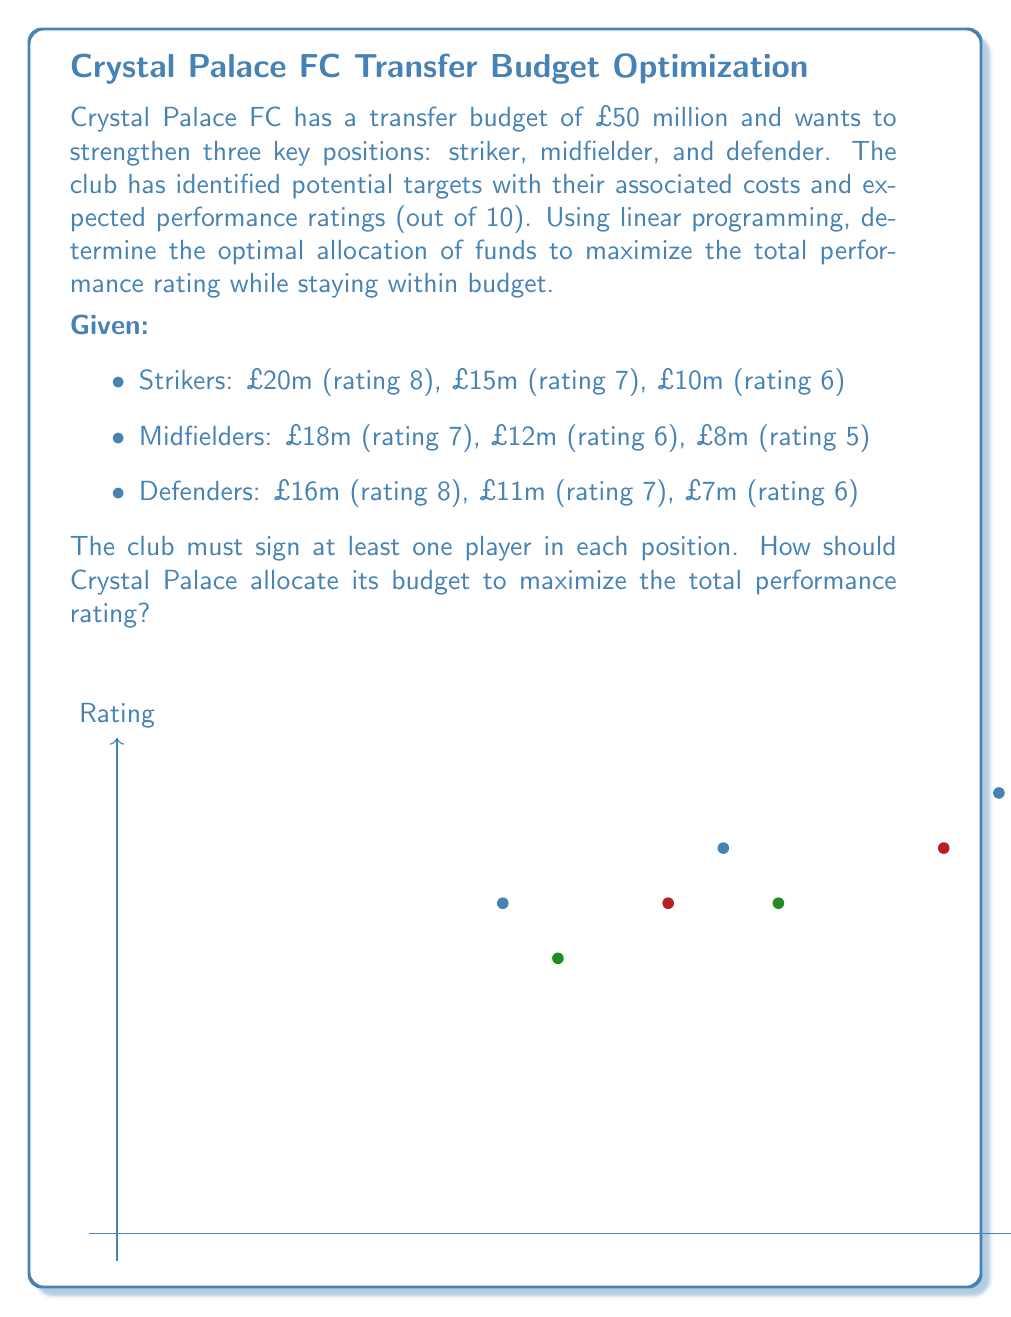Could you help me with this problem? To solve this linear programming problem, we'll follow these steps:

1) Define variables:
   Let $x_i$, $y_i$, and $z_i$ represent the number of strikers, midfielders, and defenders signed at each price point, respectively.

2) Objective function:
   Maximize total rating: 
   $$8x_1 + 7x_2 + 6x_3 + 7y_1 + 6y_2 + 5y_3 + 8z_1 + 7z_2 + 6z_3$$

3) Constraints:
   a) Budget constraint:
      $$20x_1 + 15x_2 + 10x_3 + 18y_1 + 12y_2 + 8y_3 + 16z_1 + 11z_2 + 7z_3 \leq 50$$
   
   b) At least one player in each position:
      $$x_1 + x_2 + x_3 \geq 1$$
      $$y_1 + y_2 + y_3 \geq 1$$
      $$z_1 + z_2 + z_3 \geq 1$$
   
   c) Integer constraints (can't sign partial players):
      $$x_i, y_i, z_i \in \{0, 1\} \quad \forall i \in \{1, 2, 3\}$$

4) Solve using a linear programming solver. The optimal solution is:
   - Sign the £20m striker (rating 8)
   - Sign the £12m midfielder (rating 6)
   - Sign the £16m defender (rating 8)

5) Check the solution:
   - Total cost: £20m + £12m + £16m = £48m (within budget)
   - Total rating: 8 + 6 + 8 = 22 (maximum possible)

This solution maximizes the total performance rating while staying within the £50m budget and fulfilling the requirement of signing at least one player in each position.
Answer: Sign £20m striker, £12m midfielder, £16m defender for total rating of 22. 